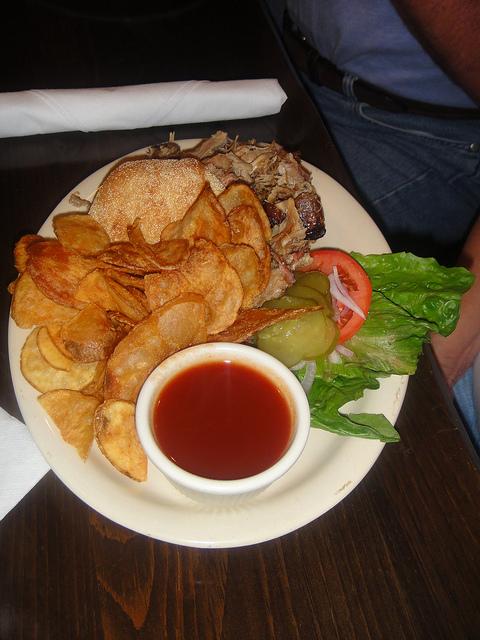What color is the plate?
Short answer required. White. What is in the bowl?
Answer briefly. Sauce. Is the plate full?
Be succinct. Yes. 